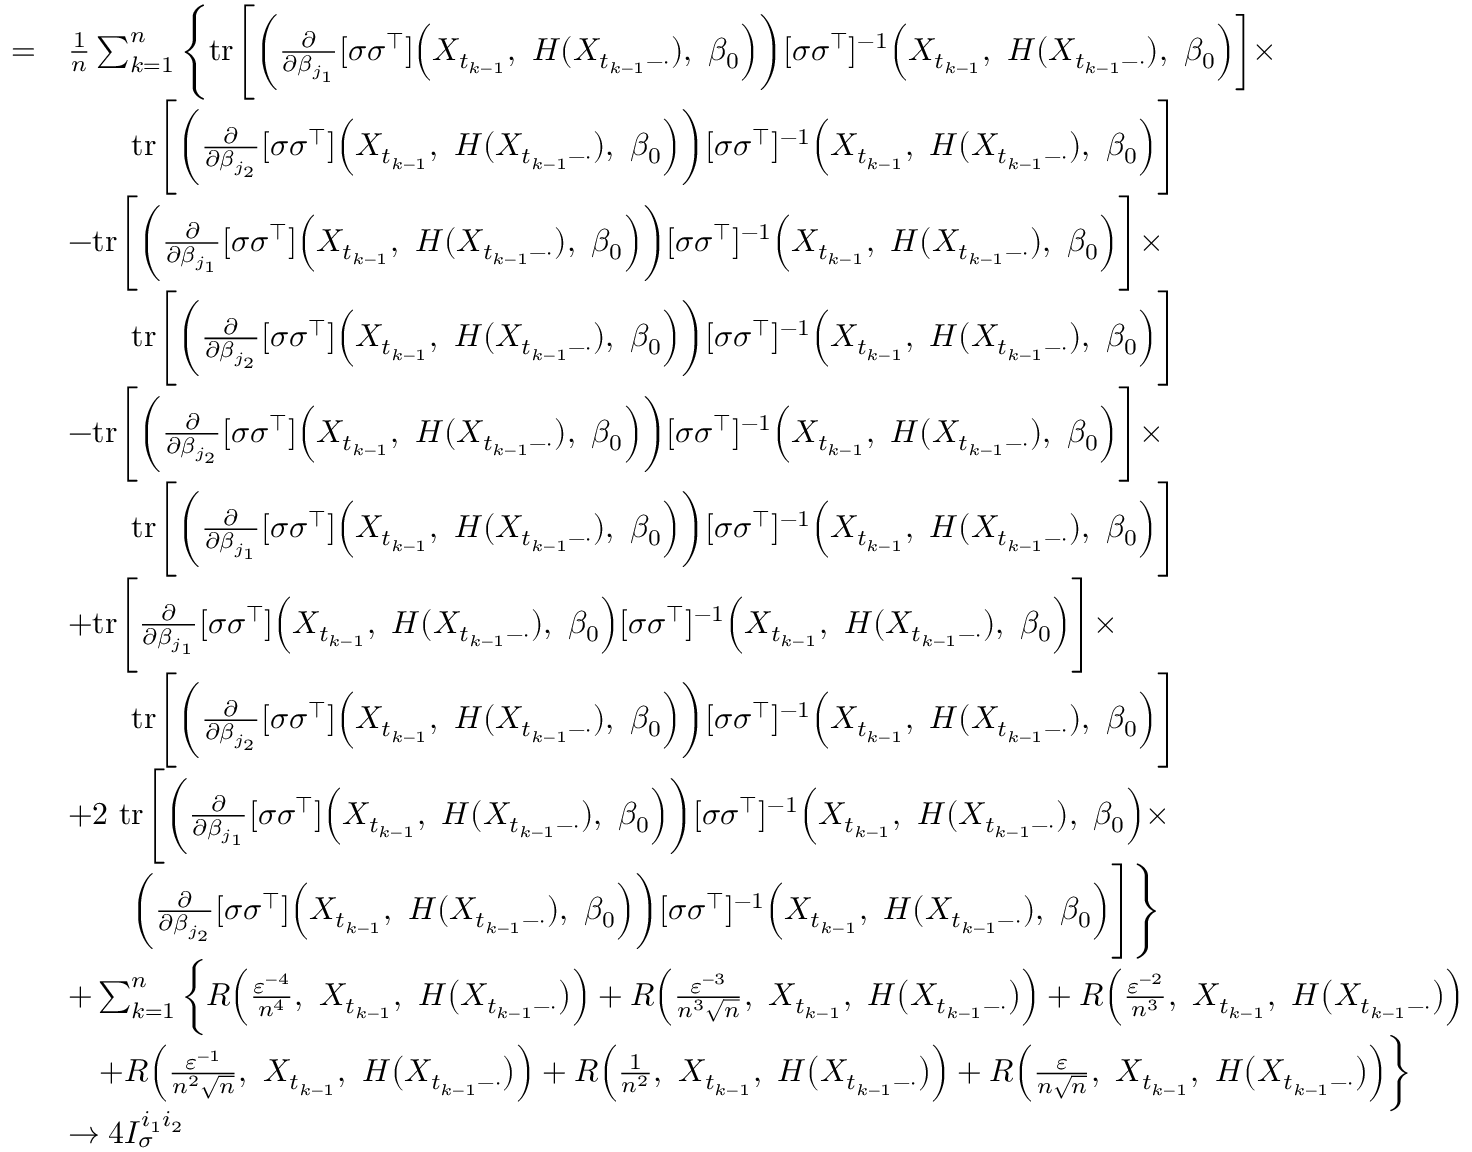<formula> <loc_0><loc_0><loc_500><loc_500>\begin{array} { r l } { = } & { \frac { 1 } { n } \sum _ { k = 1 } ^ { n } \left \{ t r \left [ \left ( \frac { \partial } { \partial \beta _ { j _ { 1 } } } [ \sigma \sigma ^ { \top } ] \left ( X _ { t _ { k - 1 } } , H ( X _ { t _ { k - 1 } - \cdot } ) , \beta _ { 0 } \right ) \right ) [ \sigma \sigma ^ { \top } ] ^ { - 1 } \left ( X _ { t _ { k - 1 } } , H ( X _ { t _ { k - 1 } - \cdot } ) , \beta _ { 0 } \right ) \right ] \times } \\ & { \quad t r \left [ \left ( \frac { \partial } { \partial \beta _ { j _ { 2 } } } [ \sigma \sigma ^ { \top } ] \left ( X _ { t _ { k - 1 } } , H ( X _ { t _ { k - 1 } - \cdot } ) , \beta _ { 0 } \right ) \right ) [ \sigma \sigma ^ { \top } ] ^ { - 1 } \left ( X _ { t _ { k - 1 } } , H ( X _ { t _ { k - 1 } - \cdot } ) , \beta _ { 0 } \right ) \right ] } \\ & { - t r \left [ \left ( \frac { \partial } { \partial \beta _ { j _ { 1 } } } [ \sigma \sigma ^ { \top } ] \left ( X _ { t _ { k - 1 } } , H ( X _ { t _ { k - 1 } - \cdot } ) , \beta _ { 0 } \right ) \right ) [ \sigma \sigma ^ { \top } ] ^ { - 1 } \left ( X _ { t _ { k - 1 } } , H ( X _ { t _ { k - 1 } - \cdot } ) , \beta _ { 0 } \right ) \right ] \times } \\ & { \quad t r \left [ \left ( \frac { \partial } { \partial \beta _ { j _ { 2 } } } [ \sigma \sigma ^ { \top } ] \left ( X _ { t _ { k - 1 } } , H ( X _ { t _ { k - 1 } - \cdot } ) , \beta _ { 0 } \right ) \right ) [ \sigma \sigma ^ { \top } ] ^ { - 1 } \left ( X _ { t _ { k - 1 } } , H ( X _ { t _ { k - 1 } - \cdot } ) , \beta _ { 0 } \right ) \right ] } \\ & { - t r \left [ \left ( \frac { \partial } { \partial \beta _ { j _ { 2 } } } [ \sigma \sigma ^ { \top } ] \left ( X _ { t _ { k - 1 } } , H ( X _ { t _ { k - 1 } - \cdot } ) , \beta _ { 0 } \right ) \right ) [ \sigma \sigma ^ { \top } ] ^ { - 1 } \left ( X _ { t _ { k - 1 } } , H ( X _ { t _ { k - 1 } - \cdot } ) , \beta _ { 0 } \right ) \right ] \times } \\ & { \quad t r \left [ \left ( \frac { \partial } { \partial \beta _ { j _ { 1 } } } [ \sigma \sigma ^ { \top } ] \left ( X _ { t _ { k - 1 } } , H ( X _ { t _ { k - 1 } - \cdot } ) , \beta _ { 0 } \right ) \right ) [ \sigma \sigma ^ { \top } ] ^ { - 1 } \left ( X _ { t _ { k - 1 } } , H ( X _ { t _ { k - 1 } - \cdot } ) , \beta _ { 0 } \right ) \right ] } \\ & { + t r \left [ \frac { \partial } { \partial \beta _ { j _ { 1 } } } [ \sigma \sigma ^ { \top } ] \left ( X _ { t _ { k - 1 } } , H ( X _ { t _ { k - 1 } - \cdot } ) , \beta _ { 0 } \right ) [ \sigma \sigma ^ { \top } ] ^ { - 1 } \left ( X _ { t _ { k - 1 } } , H ( X _ { t _ { k - 1 } - \cdot } ) , \beta _ { 0 } \right ) \right ] \times } \\ & { \quad t r \left [ \left ( \frac { \partial } { \partial \beta _ { j _ { 2 } } } [ \sigma \sigma ^ { \top } ] \left ( X _ { t _ { k - 1 } } , H ( X _ { t _ { k - 1 } - \cdot } ) , \beta _ { 0 } \right ) \right ) [ \sigma \sigma ^ { \top } ] ^ { - 1 } \left ( X _ { t _ { k - 1 } } , H ( X _ { t _ { k - 1 } - \cdot } ) , \beta _ { 0 } \right ) \right ] } \\ & { + 2 t r \left [ \left ( \frac { \partial } { \partial \beta _ { j _ { 1 } } } [ \sigma \sigma ^ { \top } ] \left ( X _ { t _ { k - 1 } } , H ( X _ { t _ { k - 1 } - \cdot } ) , \beta _ { 0 } \right ) \right ) [ \sigma \sigma ^ { \top } ] ^ { - 1 } \left ( X _ { t _ { k - 1 } } , H ( X _ { t _ { k - 1 } - \cdot } ) , \beta _ { 0 } \right ) \times } \\ & { \quad \left ( \frac { \partial } { \partial \beta _ { j _ { 2 } } } [ \sigma \sigma ^ { \top } ] \left ( X _ { t _ { k - 1 } } , H ( X _ { t _ { k - 1 } - \cdot } ) , \beta _ { 0 } \right ) \right ) [ \sigma \sigma ^ { \top } ] ^ { - 1 } \left ( X _ { t _ { k - 1 } } , H ( X _ { t _ { k - 1 } - \cdot } ) , \beta _ { 0 } \right ) \right ] \right \} } \\ & { + \sum _ { k = 1 } ^ { n } \left \{ R \left ( \frac { \varepsilon ^ { - 4 } } { n ^ { 4 } } , X _ { t _ { k - 1 } } , H \left ( X _ { t _ { k - 1 } - \cdot } \right ) \right ) + R \left ( \frac { \varepsilon ^ { - 3 } } { n ^ { 3 } \sqrt { n } } , X _ { t _ { k - 1 } } , H \left ( X _ { t _ { k - 1 } - \cdot } \right ) \right ) + R \left ( \frac { \varepsilon ^ { - 2 } } { n ^ { 3 } } , X _ { t _ { k - 1 } } , H \left ( X _ { t _ { k - 1 } - \cdot } \right ) \right ) } \\ & { \quad + R \left ( \frac { \varepsilon ^ { - 1 } } { n ^ { 2 } \sqrt { n } } , X _ { t _ { k - 1 } } , H \left ( X _ { t _ { k - 1 } - \cdot } \right ) \right ) + R \left ( \frac { 1 } { n ^ { 2 } } , X _ { t _ { k - 1 } } , H \left ( X _ { t _ { k - 1 } - \cdot } \right ) \right ) + R \left ( \frac { \varepsilon } { n \sqrt { n } } , X _ { t _ { k - 1 } } , H \left ( X _ { t _ { k - 1 } - \cdot } \right ) \right ) \right \} } \\ & { \rightarrow 4 I _ { \sigma } ^ { i _ { 1 } i _ { 2 } } } \end{array}</formula> 